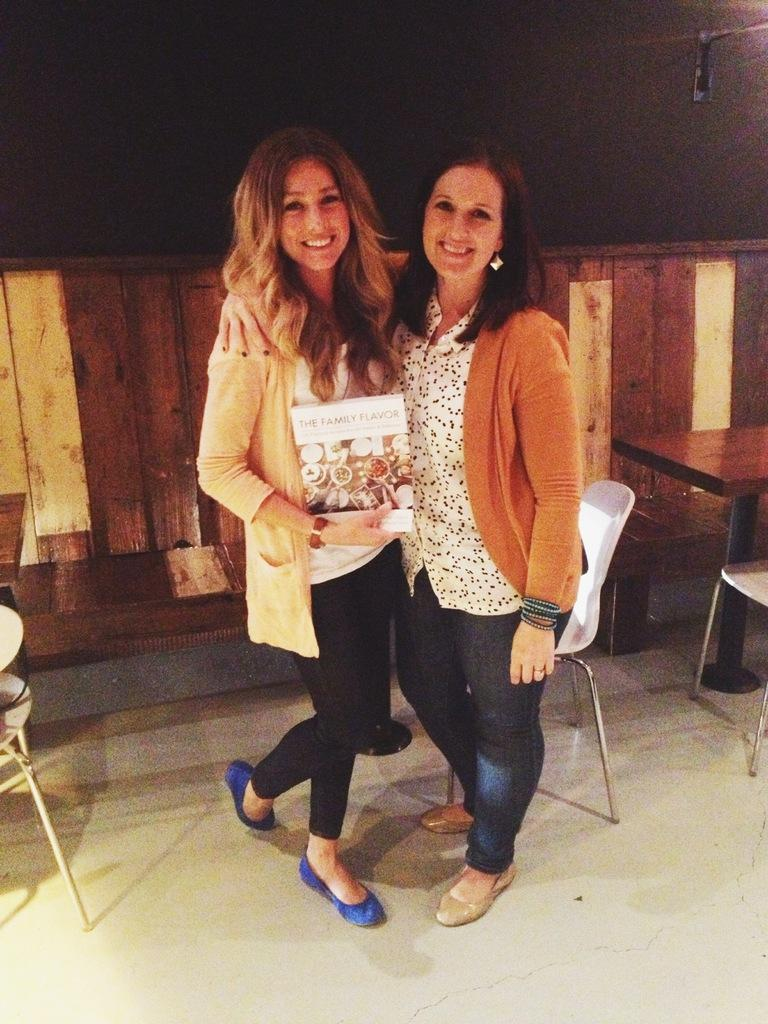How many people are in the image? There are two women in the image. What are the women doing in the image? The women are posing for a camera. Can you describe any objects that one of the women is holding? One of the women is holding a book. What type of kitten can be seen wearing a mitten in the image? There is no kitten or mitten present in the image; it features two women posing for a camera. 